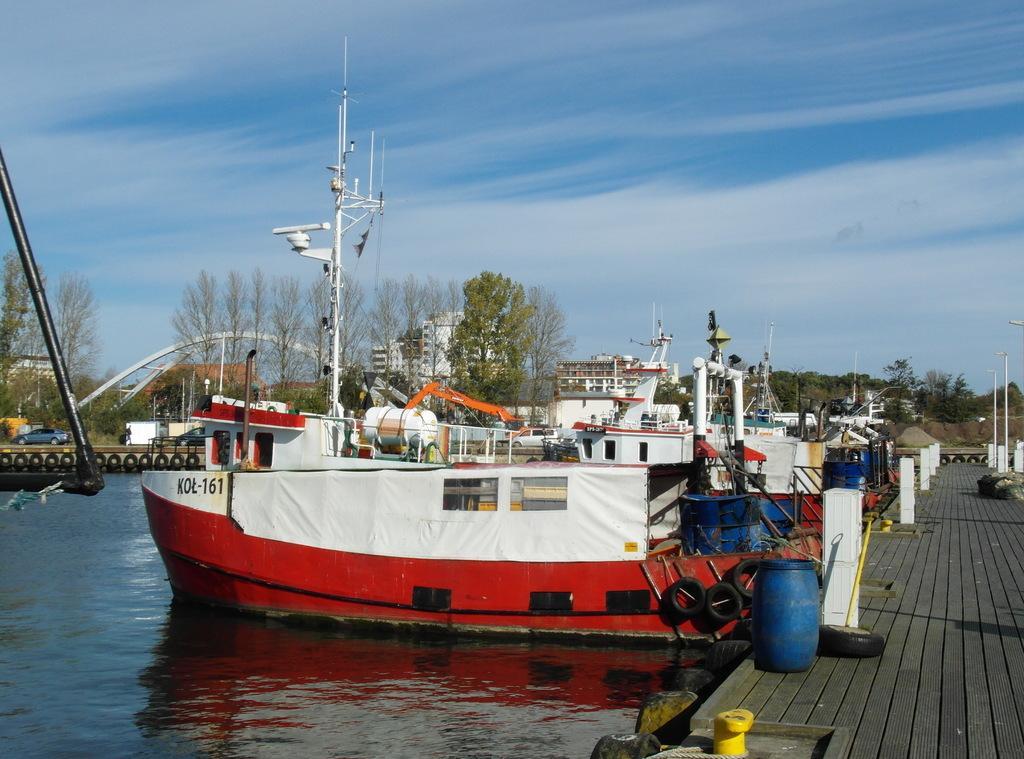Describe this image in one or two sentences. In this image we can see some boats in the water. On the right side we can see a drum, some tires, poles and a stick on the deck. On the backside we can see some tires, poles, a group of trees, buildings, the heap of sand, some vehicles on the pathway and the sky which looks cloudy. 